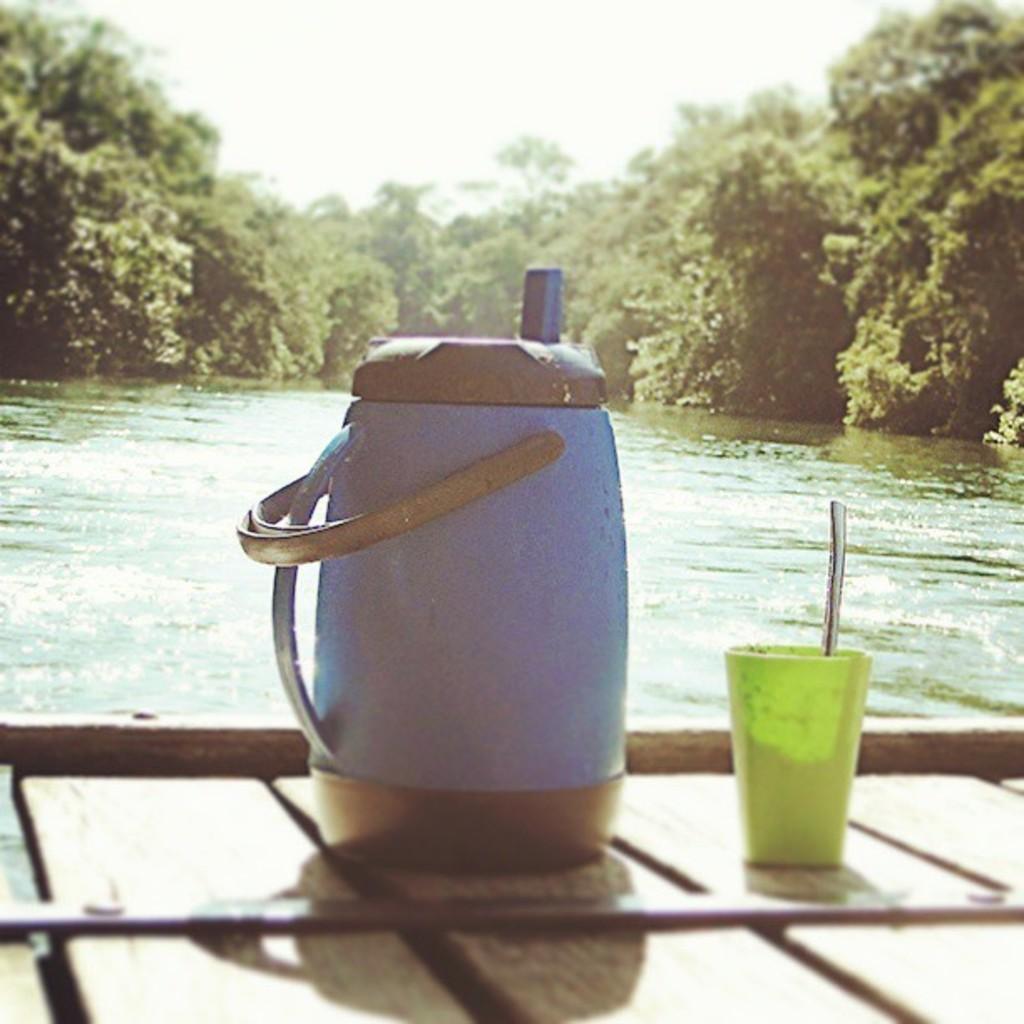In one or two sentences, can you explain what this image depicts? In this image, we can see a flask and there is a spoon in the cup are placed on the table. In the background, there are trees and there is water. 